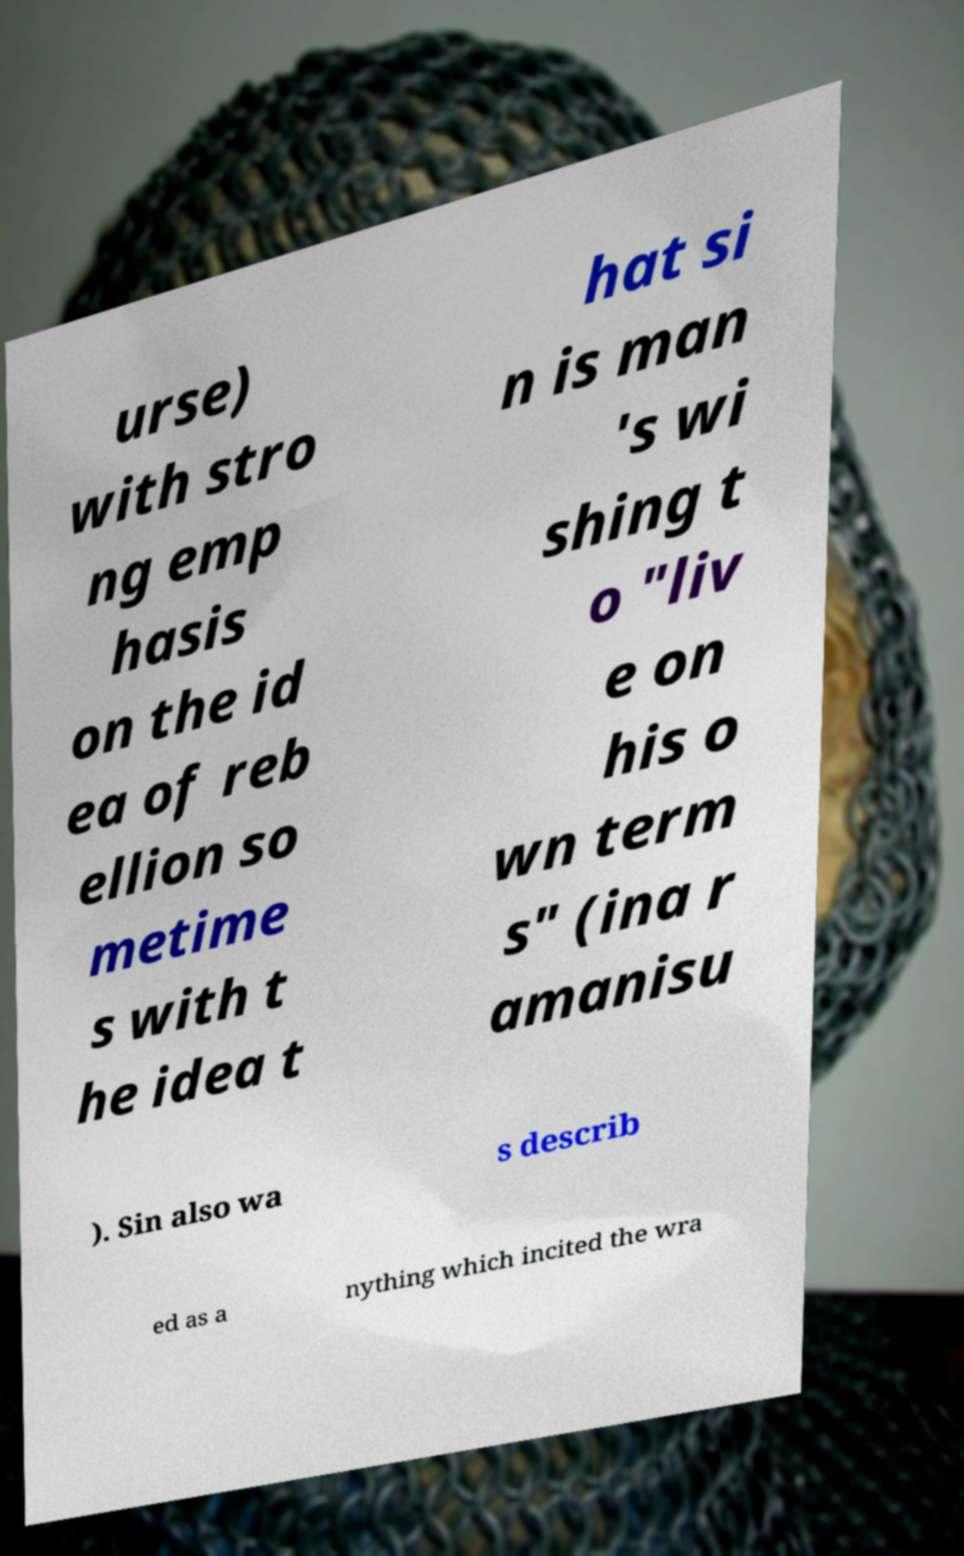Can you read and provide the text displayed in the image?This photo seems to have some interesting text. Can you extract and type it out for me? urse) with stro ng emp hasis on the id ea of reb ellion so metime s with t he idea t hat si n is man 's wi shing t o "liv e on his o wn term s" (ina r amanisu ). Sin also wa s describ ed as a nything which incited the wra 